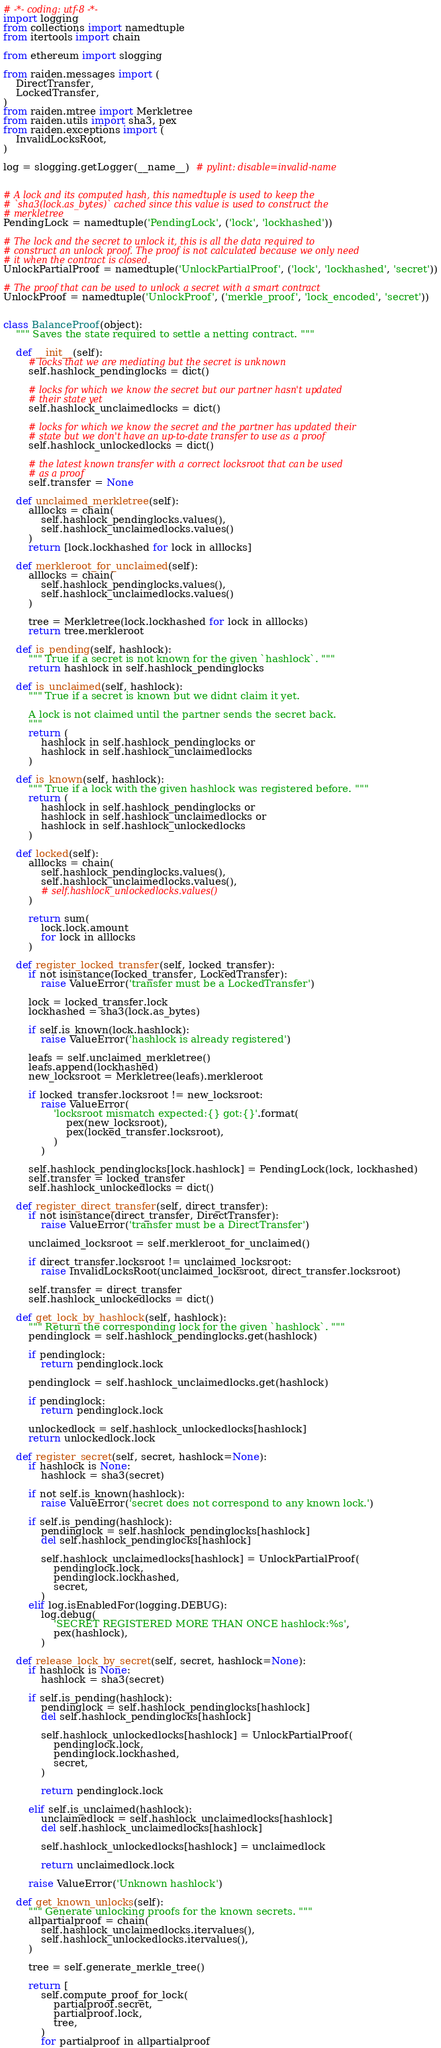<code> <loc_0><loc_0><loc_500><loc_500><_Python_># -*- coding: utf-8 -*-
import logging
from collections import namedtuple
from itertools import chain

from ethereum import slogging

from raiden.messages import (
    DirectTransfer,
    LockedTransfer,
)
from raiden.mtree import Merkletree
from raiden.utils import sha3, pex
from raiden.exceptions import (
    InvalidLocksRoot,
)

log = slogging.getLogger(__name__)  # pylint: disable=invalid-name


# A lock and its computed hash, this namedtuple is used to keep the
# `sha3(lock.as_bytes)` cached since this value is used to construct the
# merkletree
PendingLock = namedtuple('PendingLock', ('lock', 'lockhashed'))

# The lock and the secret to unlock it, this is all the data required to
# construct an unlock proof. The proof is not calculated because we only need
# it when the contract is closed.
UnlockPartialProof = namedtuple('UnlockPartialProof', ('lock', 'lockhashed', 'secret'))

# The proof that can be used to unlock a secret with a smart contract
UnlockProof = namedtuple('UnlockProof', ('merkle_proof', 'lock_encoded', 'secret'))


class BalanceProof(object):
    """ Saves the state required to settle a netting contract. """

    def __init__(self):
        # locks that we are mediating but the secret is unknown
        self.hashlock_pendinglocks = dict()

        # locks for which we know the secret but our partner hasn't updated
        # their state yet
        self.hashlock_unclaimedlocks = dict()

        # locks for which we know the secret and the partner has updated their
        # state but we don't have an up-to-date transfer to use as a proof
        self.hashlock_unlockedlocks = dict()

        # the latest known transfer with a correct locksroot that can be used
        # as a proof
        self.transfer = None

    def unclaimed_merkletree(self):
        alllocks = chain(
            self.hashlock_pendinglocks.values(),
            self.hashlock_unclaimedlocks.values()
        )
        return [lock.lockhashed for lock in alllocks]

    def merkleroot_for_unclaimed(self):
        alllocks = chain(
            self.hashlock_pendinglocks.values(),
            self.hashlock_unclaimedlocks.values()
        )

        tree = Merkletree(lock.lockhashed for lock in alllocks)
        return tree.merkleroot

    def is_pending(self, hashlock):
        """ True if a secret is not known for the given `hashlock`. """
        return hashlock in self.hashlock_pendinglocks

    def is_unclaimed(self, hashlock):
        """ True if a secret is known but we didnt claim it yet.

        A lock is not claimed until the partner sends the secret back.
        """
        return (
            hashlock in self.hashlock_pendinglocks or
            hashlock in self.hashlock_unclaimedlocks
        )

    def is_known(self, hashlock):
        """ True if a lock with the given hashlock was registered before. """
        return (
            hashlock in self.hashlock_pendinglocks or
            hashlock in self.hashlock_unclaimedlocks or
            hashlock in self.hashlock_unlockedlocks
        )

    def locked(self):
        alllocks = chain(
            self.hashlock_pendinglocks.values(),
            self.hashlock_unclaimedlocks.values(),
            # self.hashlock_unlockedlocks.values()
        )

        return sum(
            lock.lock.amount
            for lock in alllocks
        )

    def register_locked_transfer(self, locked_transfer):
        if not isinstance(locked_transfer, LockedTransfer):
            raise ValueError('transfer must be a LockedTransfer')

        lock = locked_transfer.lock
        lockhashed = sha3(lock.as_bytes)

        if self.is_known(lock.hashlock):
            raise ValueError('hashlock is already registered')

        leafs = self.unclaimed_merkletree()
        leafs.append(lockhashed)
        new_locksroot = Merkletree(leafs).merkleroot

        if locked_transfer.locksroot != new_locksroot:
            raise ValueError(
                'locksroot mismatch expected:{} got:{}'.format(
                    pex(new_locksroot),
                    pex(locked_transfer.locksroot),
                )
            )

        self.hashlock_pendinglocks[lock.hashlock] = PendingLock(lock, lockhashed)
        self.transfer = locked_transfer
        self.hashlock_unlockedlocks = dict()

    def register_direct_transfer(self, direct_transfer):
        if not isinstance(direct_transfer, DirectTransfer):
            raise ValueError('transfer must be a DirectTransfer')

        unclaimed_locksroot = self.merkleroot_for_unclaimed()

        if direct_transfer.locksroot != unclaimed_locksroot:
            raise InvalidLocksRoot(unclaimed_locksroot, direct_transfer.locksroot)

        self.transfer = direct_transfer
        self.hashlock_unlockedlocks = dict()

    def get_lock_by_hashlock(self, hashlock):
        """ Return the corresponding lock for the given `hashlock`. """
        pendinglock = self.hashlock_pendinglocks.get(hashlock)

        if pendinglock:
            return pendinglock.lock

        pendinglock = self.hashlock_unclaimedlocks.get(hashlock)

        if pendinglock:
            return pendinglock.lock

        unlockedlock = self.hashlock_unlockedlocks[hashlock]
        return unlockedlock.lock

    def register_secret(self, secret, hashlock=None):
        if hashlock is None:
            hashlock = sha3(secret)

        if not self.is_known(hashlock):
            raise ValueError('secret does not correspond to any known lock.')

        if self.is_pending(hashlock):
            pendinglock = self.hashlock_pendinglocks[hashlock]
            del self.hashlock_pendinglocks[hashlock]

            self.hashlock_unclaimedlocks[hashlock] = UnlockPartialProof(
                pendinglock.lock,
                pendinglock.lockhashed,
                secret,
            )
        elif log.isEnabledFor(logging.DEBUG):
            log.debug(
                'SECRET REGISTERED MORE THAN ONCE hashlock:%s',
                pex(hashlock),
            )

    def release_lock_by_secret(self, secret, hashlock=None):
        if hashlock is None:
            hashlock = sha3(secret)

        if self.is_pending(hashlock):
            pendinglock = self.hashlock_pendinglocks[hashlock]
            del self.hashlock_pendinglocks[hashlock]

            self.hashlock_unlockedlocks[hashlock] = UnlockPartialProof(
                pendinglock.lock,
                pendinglock.lockhashed,
                secret,
            )

            return pendinglock.lock

        elif self.is_unclaimed(hashlock):
            unclaimedlock = self.hashlock_unclaimedlocks[hashlock]
            del self.hashlock_unclaimedlocks[hashlock]

            self.hashlock_unlockedlocks[hashlock] = unclaimedlock

            return unclaimedlock.lock

        raise ValueError('Unknown hashlock')

    def get_known_unlocks(self):
        """ Generate unlocking proofs for the known secrets. """
        allpartialproof = chain(
            self.hashlock_unclaimedlocks.itervalues(),
            self.hashlock_unlockedlocks.itervalues(),
        )

        tree = self.generate_merkle_tree()

        return [
            self.compute_proof_for_lock(
                partialproof.secret,
                partialproof.lock,
                tree,
            )
            for partialproof in allpartialproof</code> 